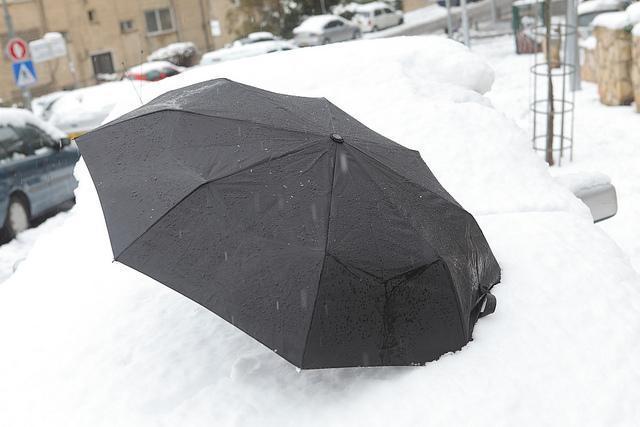How many cars are there?
Give a very brief answer. 2. How many people holding a tennis racket?
Give a very brief answer. 0. 